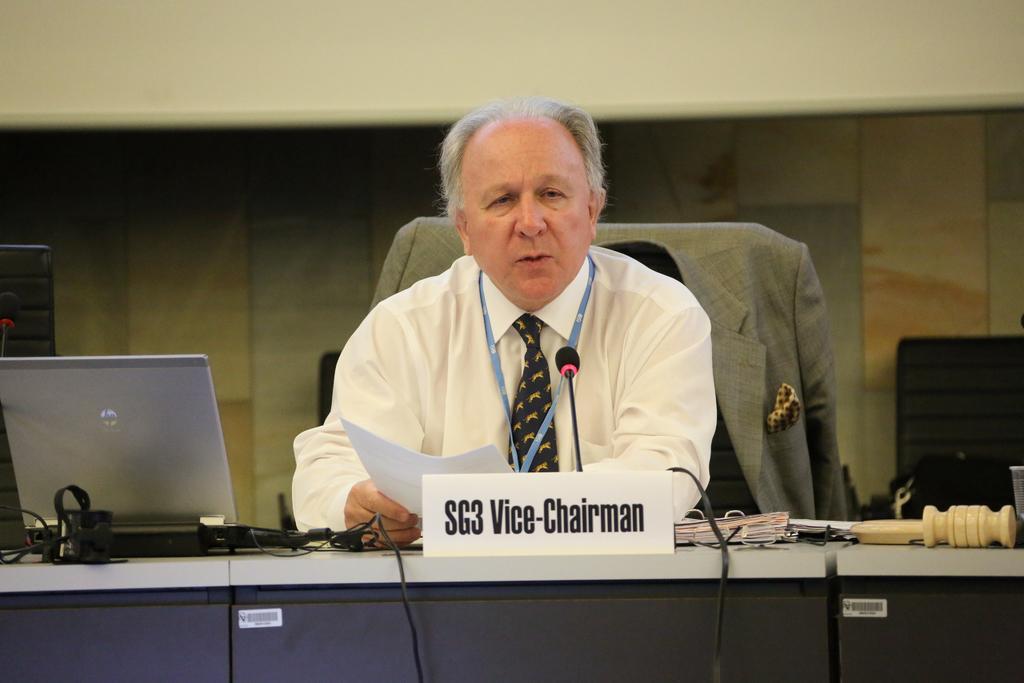Can you describe this image briefly? In this image I can see the person sitting in-front of the table. On the table I can see the laptop, wires, board and few objects. I can see the person holding the paper. There is a blazer on the chair. In the background I can see the black color objects, screen and the wall. 